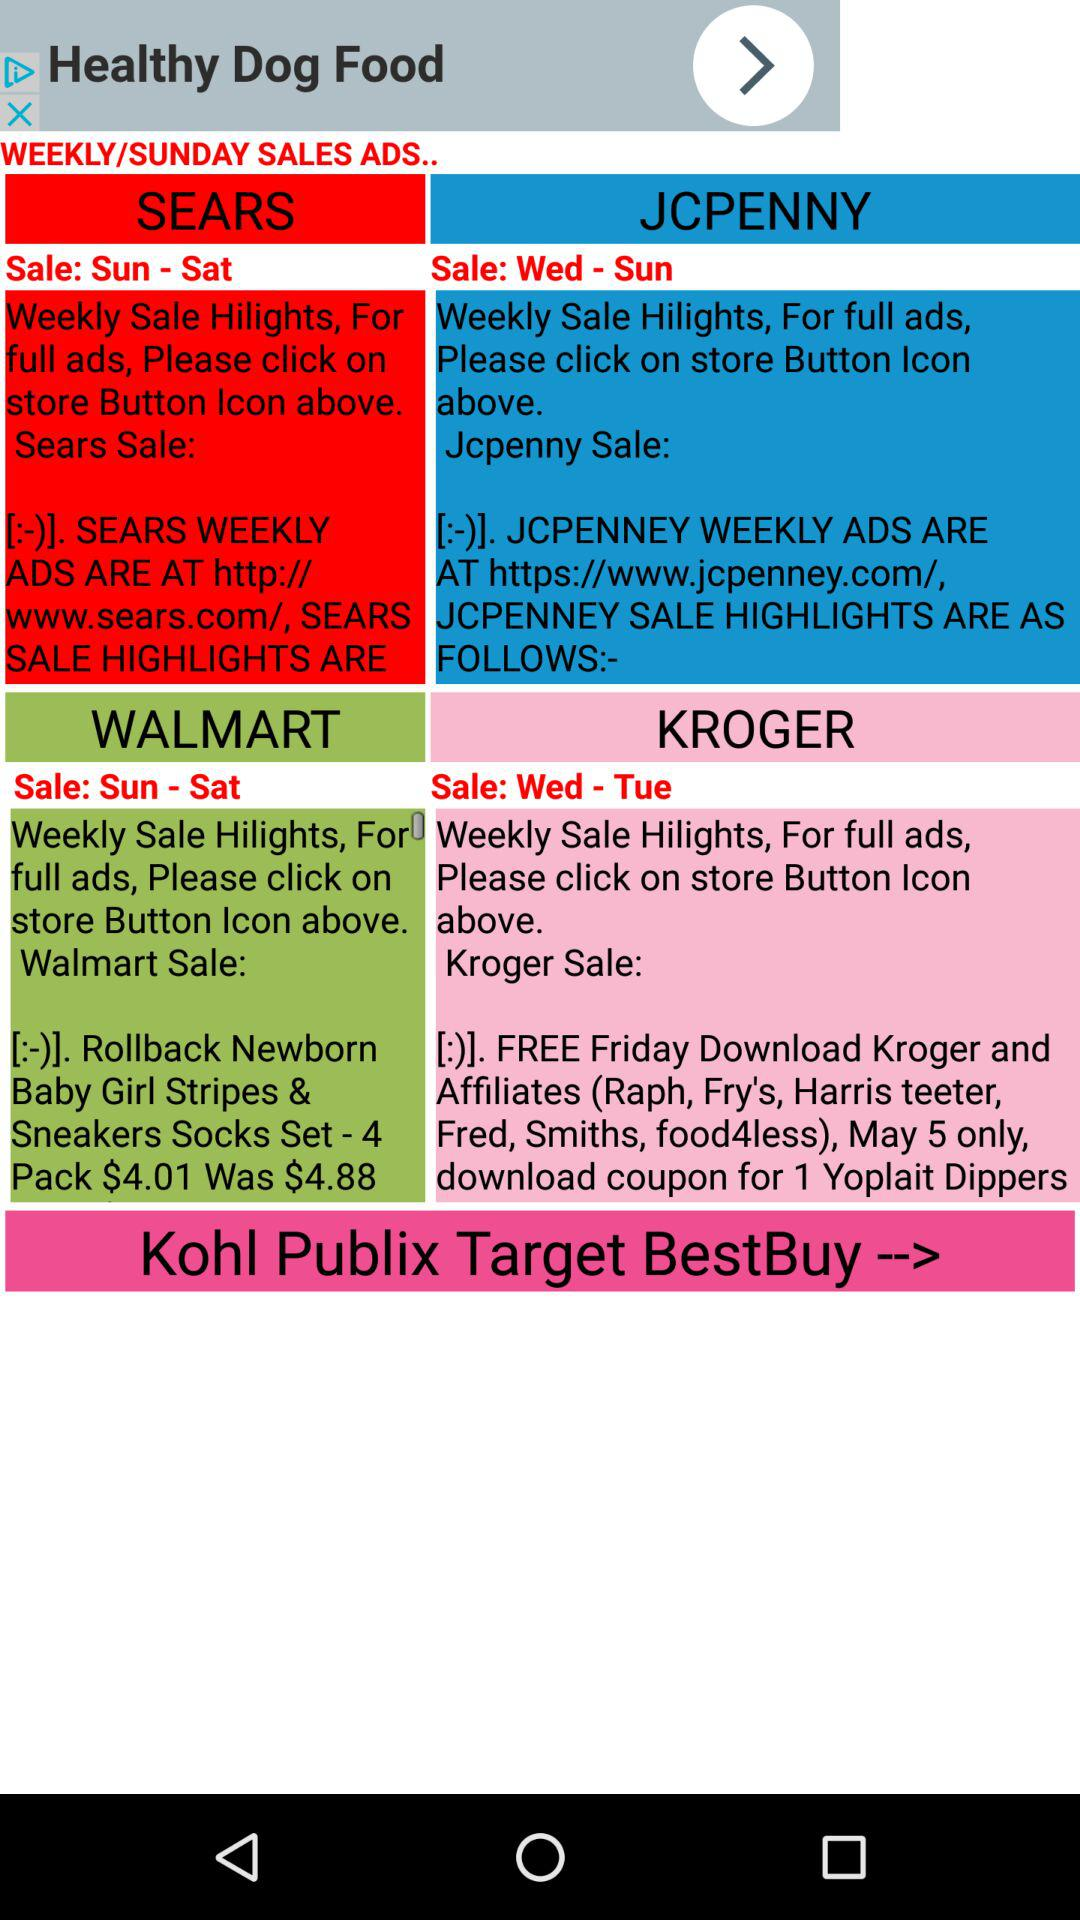What is sale date of sears?
When the provided information is insufficient, respond with <no answer>. <no answer> 